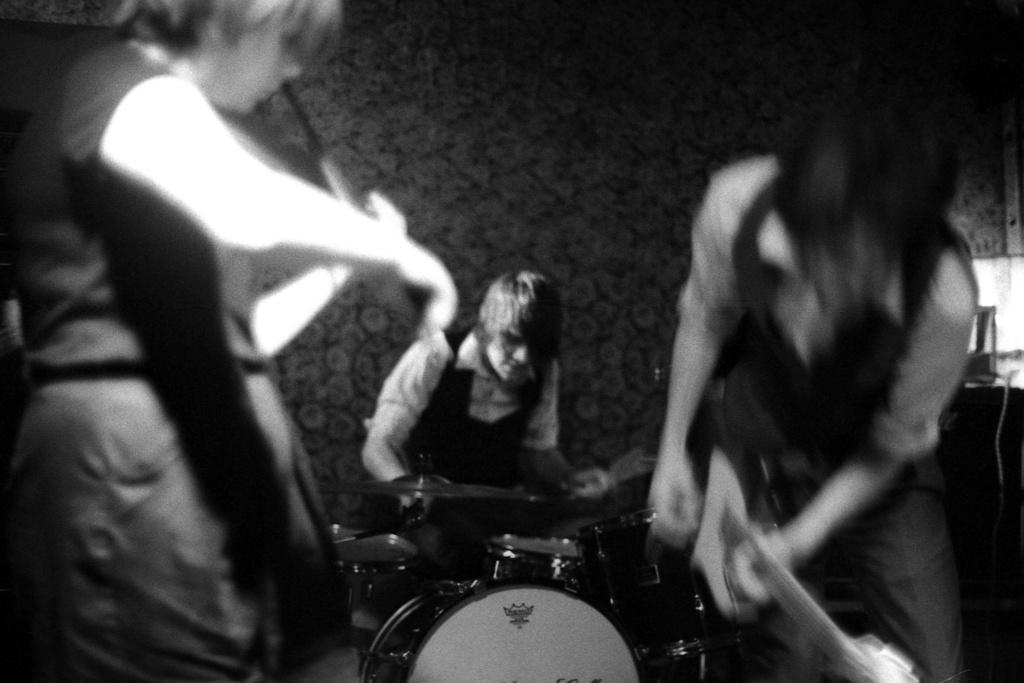How would you summarize this image in a sentence or two? In this image there are three people playing musical instruments. Right side there is a person holding a guitar. Left side there is a person playing a violin. Background there is a wall. 